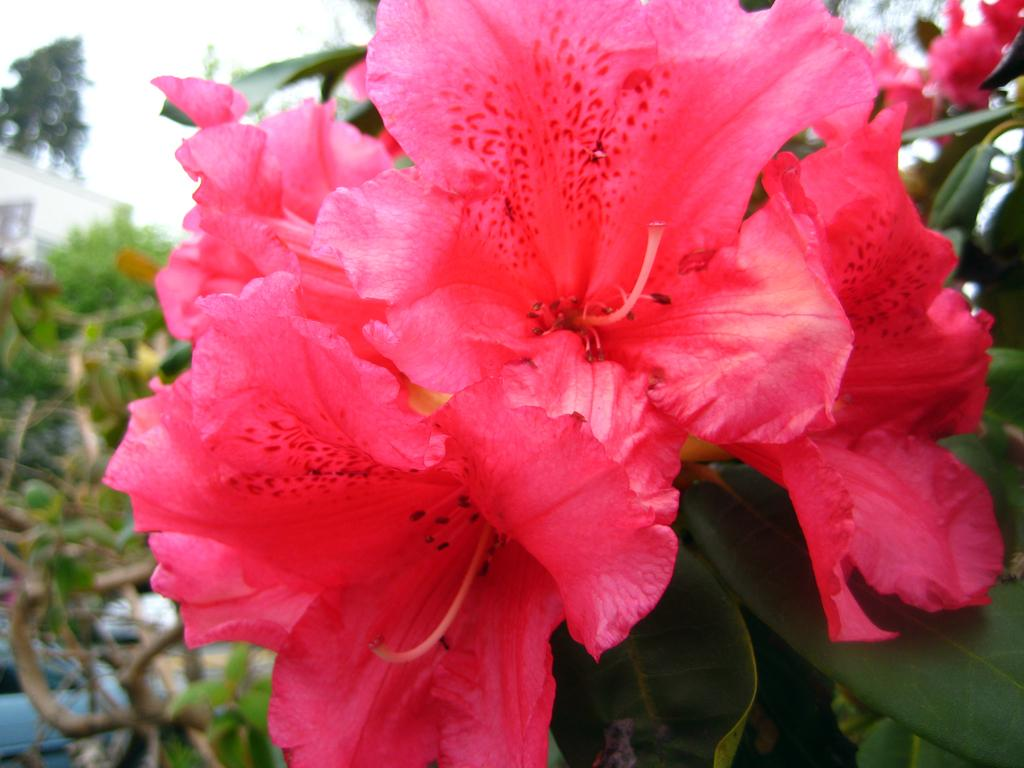What type of flora is present in the image? There are flowers in the image. What color are the flowers? The flowers are pink in color. What can be seen in the background of the image? There are trees and a building in the background of the image. What is the color of the building? The building is white in color. How is the background of the image? The background of the image is blurred. How many toes can be seen in the image? There are no toes visible in the image. 